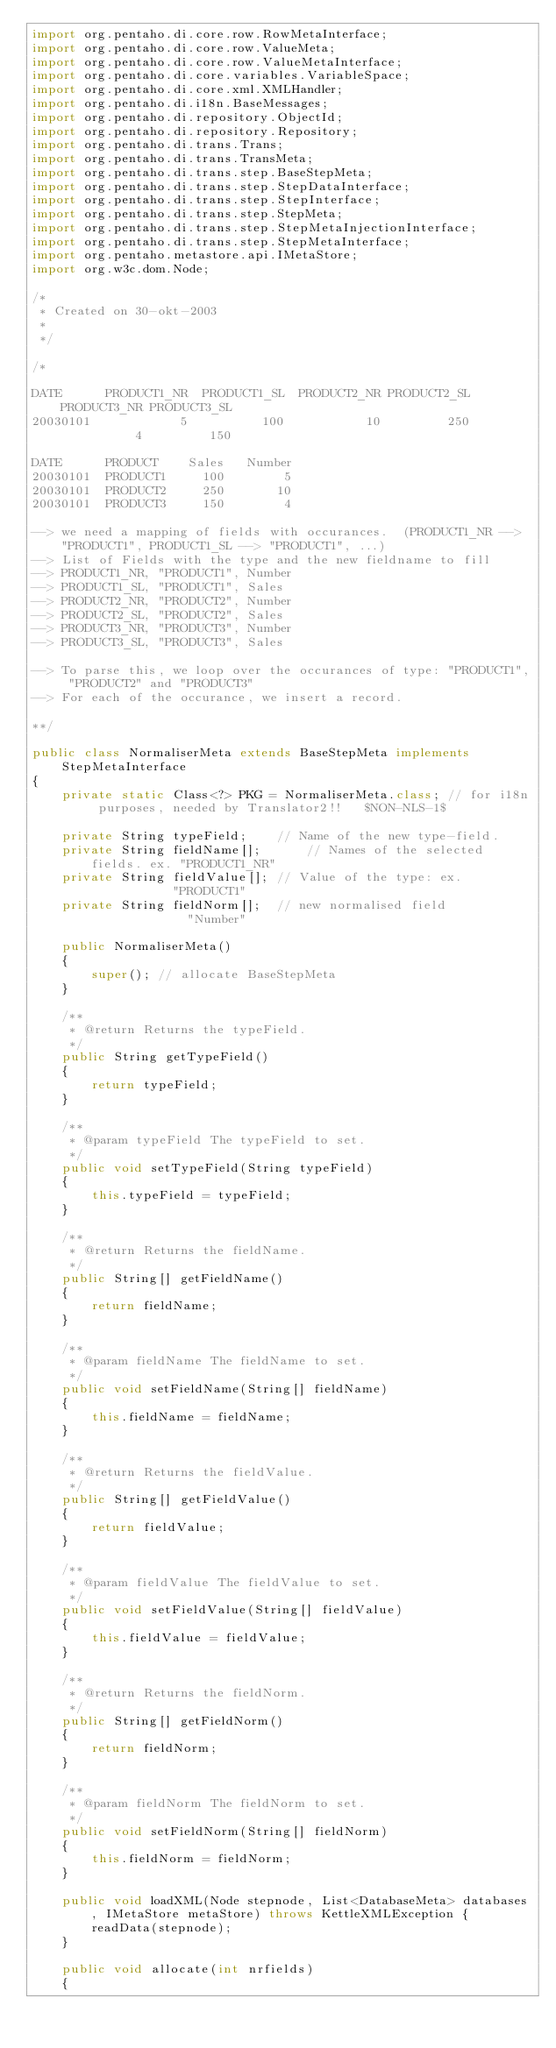Convert code to text. <code><loc_0><loc_0><loc_500><loc_500><_Java_>import org.pentaho.di.core.row.RowMetaInterface;
import org.pentaho.di.core.row.ValueMeta;
import org.pentaho.di.core.row.ValueMetaInterface;
import org.pentaho.di.core.variables.VariableSpace;
import org.pentaho.di.core.xml.XMLHandler;
import org.pentaho.di.i18n.BaseMessages;
import org.pentaho.di.repository.ObjectId;
import org.pentaho.di.repository.Repository;
import org.pentaho.di.trans.Trans;
import org.pentaho.di.trans.TransMeta;
import org.pentaho.di.trans.step.BaseStepMeta;
import org.pentaho.di.trans.step.StepDataInterface;
import org.pentaho.di.trans.step.StepInterface;
import org.pentaho.di.trans.step.StepMeta;
import org.pentaho.di.trans.step.StepMetaInjectionInterface;
import org.pentaho.di.trans.step.StepMetaInterface;
import org.pentaho.metastore.api.IMetaStore;
import org.w3c.dom.Node;

/*
 * Created on 30-okt-2003
 *
 */

/*

DATE      PRODUCT1_NR  PRODUCT1_SL  PRODUCT2_NR PRODUCT2_SL PRODUCT3_NR PRODUCT3_SL 
20030101            5          100           10         250           4         150
          
DATE      PRODUCT    Sales   Number  
20030101  PRODUCT1     100        5
20030101  PRODUCT2     250       10
20030101  PRODUCT3     150        4

--> we need a mapping of fields with occurances.  (PRODUCT1_NR --> "PRODUCT1", PRODUCT1_SL --> "PRODUCT1", ...)
--> List of Fields with the type and the new fieldname to fill
--> PRODUCT1_NR, "PRODUCT1", Number
--> PRODUCT1_SL, "PRODUCT1", Sales
--> PRODUCT2_NR, "PRODUCT2", Number
--> PRODUCT2_SL, "PRODUCT2", Sales
--> PRODUCT3_NR, "PRODUCT3", Number
--> PRODUCT3_SL, "PRODUCT3", Sales

--> To parse this, we loop over the occurances of type: "PRODUCT1", "PRODUCT2" and "PRODUCT3"
--> For each of the occurance, we insert a record.

**/
 
public class NormaliserMeta extends BaseStepMeta implements StepMetaInterface
{
	private static Class<?> PKG = NormaliserMeta.class; // for i18n purposes, needed by Translator2!!   $NON-NLS-1$

	private String typeField;    // Name of the new type-field.
	private String fieldName[];      // Names of the selected fields. ex. "PRODUCT1_NR"
	private String fieldValue[]; // Value of the type: ex.            "PRODUCT1"
	private String fieldNorm[];  // new normalised field              "Number"
	
	public NormaliserMeta()
	{
		super(); // allocate BaseStepMeta
	}
	
	/**
     * @return Returns the typeField.
     */
    public String getTypeField()
    {
        return typeField;
    }
    
    /**
     * @param typeField The typeField to set.
     */
    public void setTypeField(String typeField)
    {
        this.typeField = typeField;
    }
    
    /**
     * @return Returns the fieldName.
     */
    public String[] getFieldName()
    {
        return fieldName;
    }
    
    /**
     * @param fieldName The fieldName to set.
     */
    public void setFieldName(String[] fieldName)
    {
        this.fieldName = fieldName;
    }
    
    /**
     * @return Returns the fieldValue.
     */
    public String[] getFieldValue()
    {
        return fieldValue;
    }
    
    /**
     * @param fieldValue The fieldValue to set.
     */
    public void setFieldValue(String[] fieldValue)
    {
        this.fieldValue = fieldValue;
    }
    
    /**
     * @return Returns the fieldNorm.
     */
    public String[] getFieldNorm()
    {
        return fieldNorm;
    }
    
    /**
     * @param fieldNorm The fieldNorm to set.
     */
    public void setFieldNorm(String[] fieldNorm)
    {
        this.fieldNorm = fieldNorm;
    }
	
    public void loadXML(Node stepnode, List<DatabaseMeta> databases, IMetaStore metaStore) throws KettleXMLException {
		readData(stepnode);
	}

	public void allocate(int nrfields)
	{</code> 